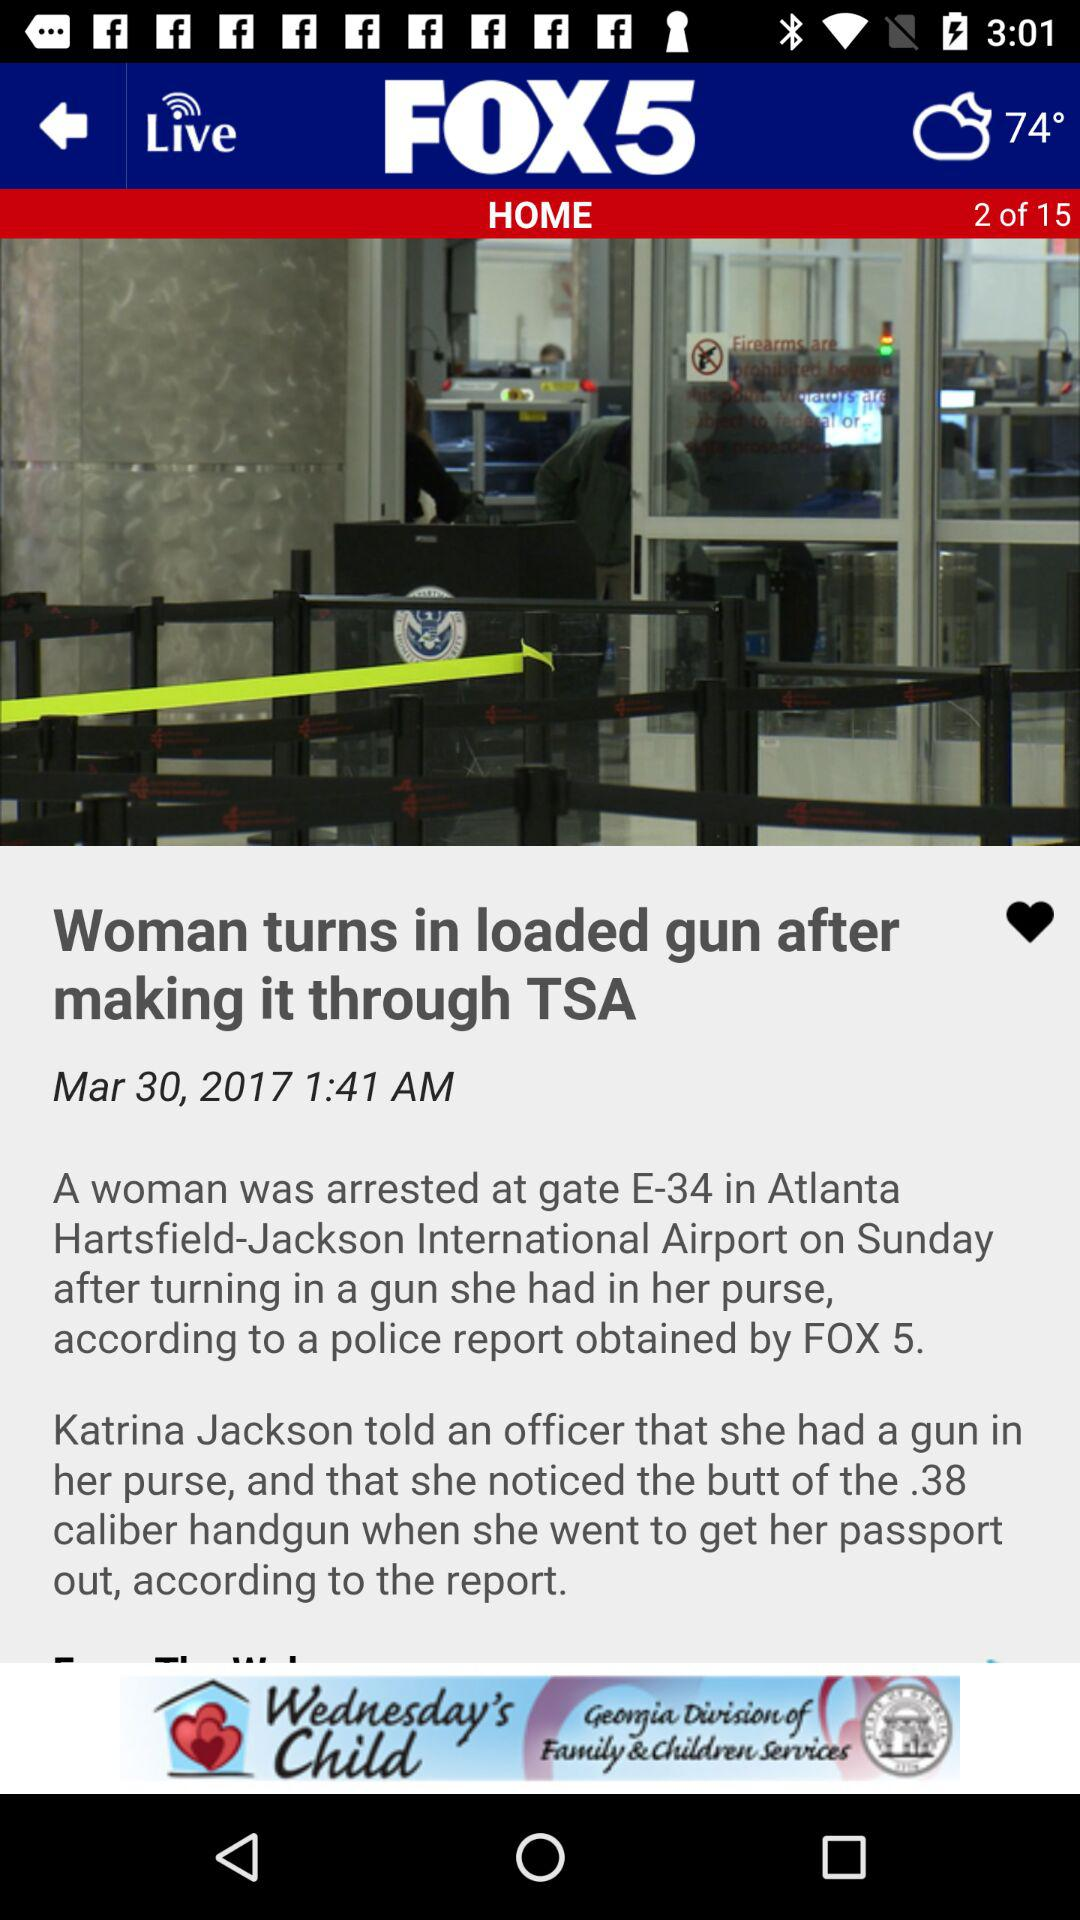What is the weather forecast? The weather is partly cloudy. 